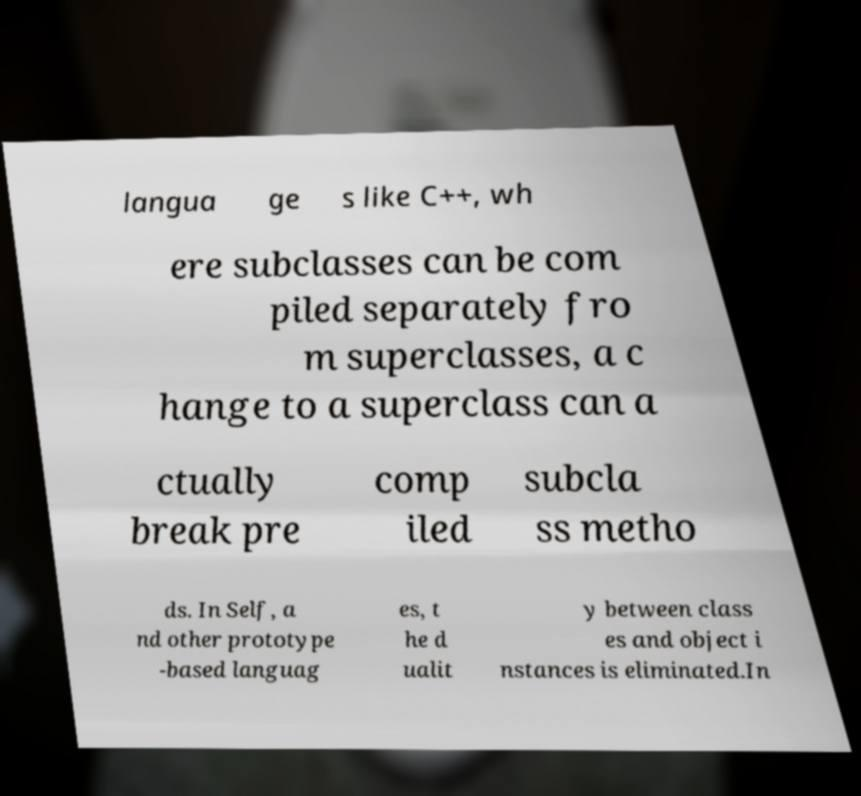I need the written content from this picture converted into text. Can you do that? langua ge s like C++, wh ere subclasses can be com piled separately fro m superclasses, a c hange to a superclass can a ctually break pre comp iled subcla ss metho ds. In Self, a nd other prototype -based languag es, t he d ualit y between class es and object i nstances is eliminated.In 